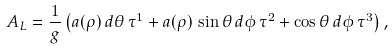Convert formula to latex. <formula><loc_0><loc_0><loc_500><loc_500>A _ { L } = \frac { 1 } { g } \left ( a ( \rho ) \, d \theta \, \tau ^ { 1 } + a ( \rho ) \, \sin \theta \, d \phi \, \tau ^ { 2 } + \cos \theta \, d \phi \, \tau ^ { 3 } \right ) ,</formula> 